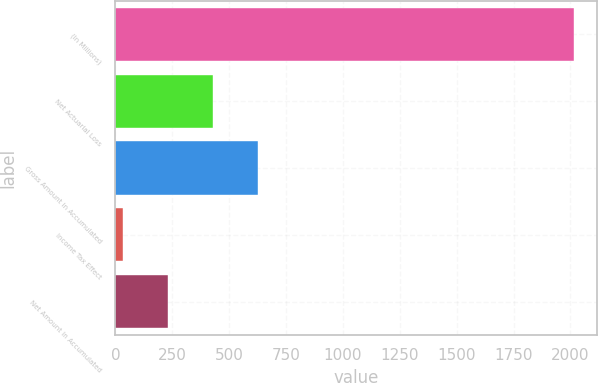Convert chart. <chart><loc_0><loc_0><loc_500><loc_500><bar_chart><fcel>(In Millions)<fcel>Net Actuarial Loss<fcel>Gross Amount in Accumulated<fcel>Income Tax Effect<fcel>Net Amount in Accumulated<nl><fcel>2017<fcel>428.92<fcel>627.43<fcel>31.9<fcel>230.41<nl></chart> 